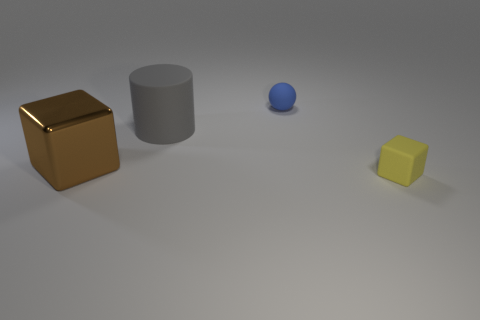Add 4 large gray shiny spheres. How many objects exist? 8 Subtract all cylinders. How many objects are left? 3 Add 1 big blue rubber cubes. How many big blue rubber cubes exist? 1 Subtract 1 brown blocks. How many objects are left? 3 Subtract all brown shiny blocks. Subtract all matte objects. How many objects are left? 0 Add 1 blocks. How many blocks are left? 3 